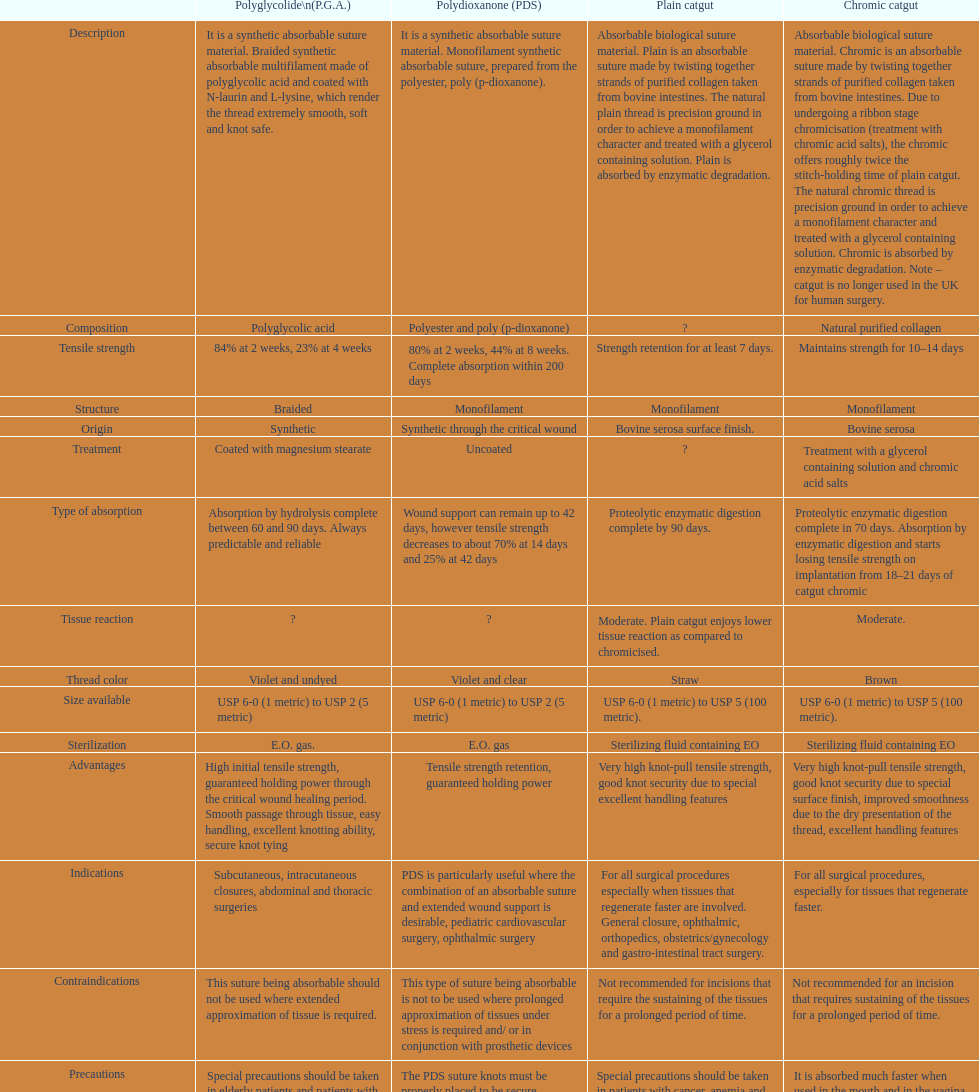What is the composition apart from monofilament? Braided. 